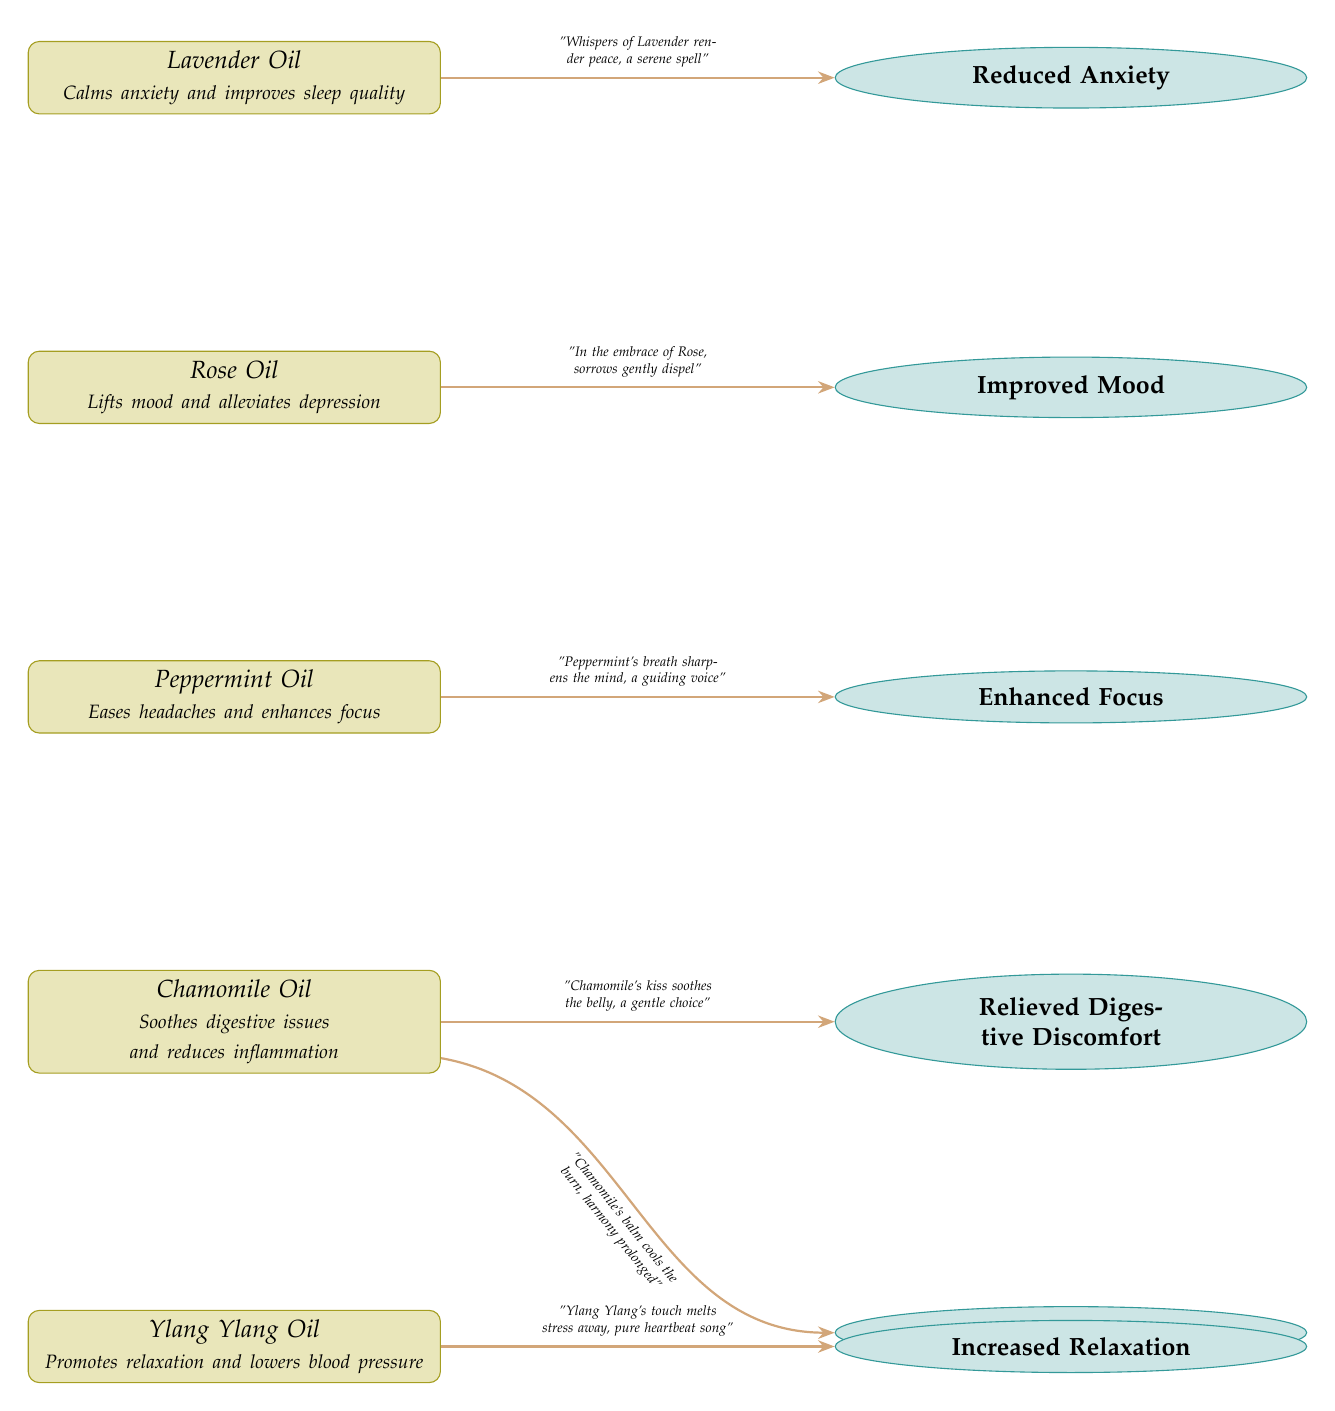What essential oil is linked to reduced anxiety? The diagram shows a direct connection between Lavender Oil and the effect of Reduced Anxiety, indicating that Lavender Oil is associated with this outcome.
Answer: Lavender Oil How many essential oils are depicted in the diagram? By counting the nodes labeled with essential oils in the diagram, we find there are five distinct oils represented: Lavender, Rose, Peppermint, Chamomile, and Ylang Ylang.
Answer: 5 Which oil is associated with improved mood? The diagram connects Rose Oil to the effect of Improved Mood, denoting its uplifting properties in relation to mood enhancement.
Answer: Rose Oil What effect is Chamomile Oil known to relieve? Chamomile Oil has arrows pointing toward both Relieved Digestive Discomfort and Reduced Inflammation, showing that it is linked to easing those specific issues.
Answer: Relieved Digestive Discomfort and Reduced Inflammation Which essential oil has the effect of increased relaxation? The diagram indicates that Ylang Ylang Oil leads to the effect of Increased Relaxation, demonstrating its calming influence.
Answer: Ylang Ylang Oil Which essential oil is described as a guiding voice? According to the diagram, Peppermint Oil is described as having the quality of sharpening the mind and being a guiding voice, illustrated in the poetic note above its connected effect.
Answer: Peppermint Oil What floral oil is associated with reducing inflammation? The diagram shows that Chamomile Oil has a direct connection to the effect of Reduced Inflammation, representing its capability to alleviate inflamed conditions.
Answer: Chamomile Oil Which essential oil improves focus? The connection in the diagram shows that Peppermint Oil is associated with the effect of Enhanced Focus, indicating its capability to sharpen concentration.
Answer: Peppermint Oil 